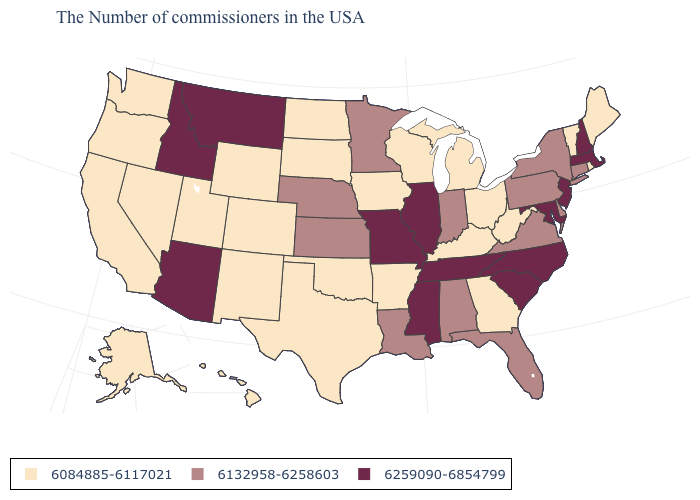Does the first symbol in the legend represent the smallest category?
Answer briefly. Yes. Which states hav the highest value in the West?
Quick response, please. Montana, Arizona, Idaho. Among the states that border Montana , which have the lowest value?
Short answer required. South Dakota, North Dakota, Wyoming. What is the value of Connecticut?
Write a very short answer. 6132958-6258603. What is the lowest value in states that border Arkansas?
Quick response, please. 6084885-6117021. Which states have the lowest value in the USA?
Quick response, please. Maine, Rhode Island, Vermont, West Virginia, Ohio, Georgia, Michigan, Kentucky, Wisconsin, Arkansas, Iowa, Oklahoma, Texas, South Dakota, North Dakota, Wyoming, Colorado, New Mexico, Utah, Nevada, California, Washington, Oregon, Alaska, Hawaii. Name the states that have a value in the range 6132958-6258603?
Answer briefly. Connecticut, New York, Delaware, Pennsylvania, Virginia, Florida, Indiana, Alabama, Louisiana, Minnesota, Kansas, Nebraska. Among the states that border New York , does Massachusetts have the lowest value?
Be succinct. No. What is the value of New Mexico?
Short answer required. 6084885-6117021. What is the lowest value in states that border Kentucky?
Quick response, please. 6084885-6117021. What is the lowest value in the West?
Be succinct. 6084885-6117021. Does Maryland have the highest value in the USA?
Be succinct. Yes. What is the highest value in states that border Alabama?
Write a very short answer. 6259090-6854799. Does the map have missing data?
Be succinct. No. What is the highest value in the USA?
Give a very brief answer. 6259090-6854799. 